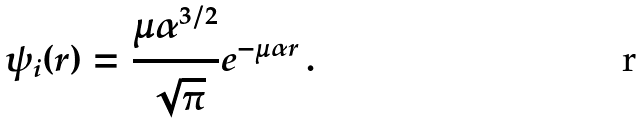<formula> <loc_0><loc_0><loc_500><loc_500>\psi _ { i } ( r ) = \frac { \mu \alpha ^ { 3 / 2 } } { \sqrt { \pi } } e ^ { - \mu \alpha r } \, .</formula> 